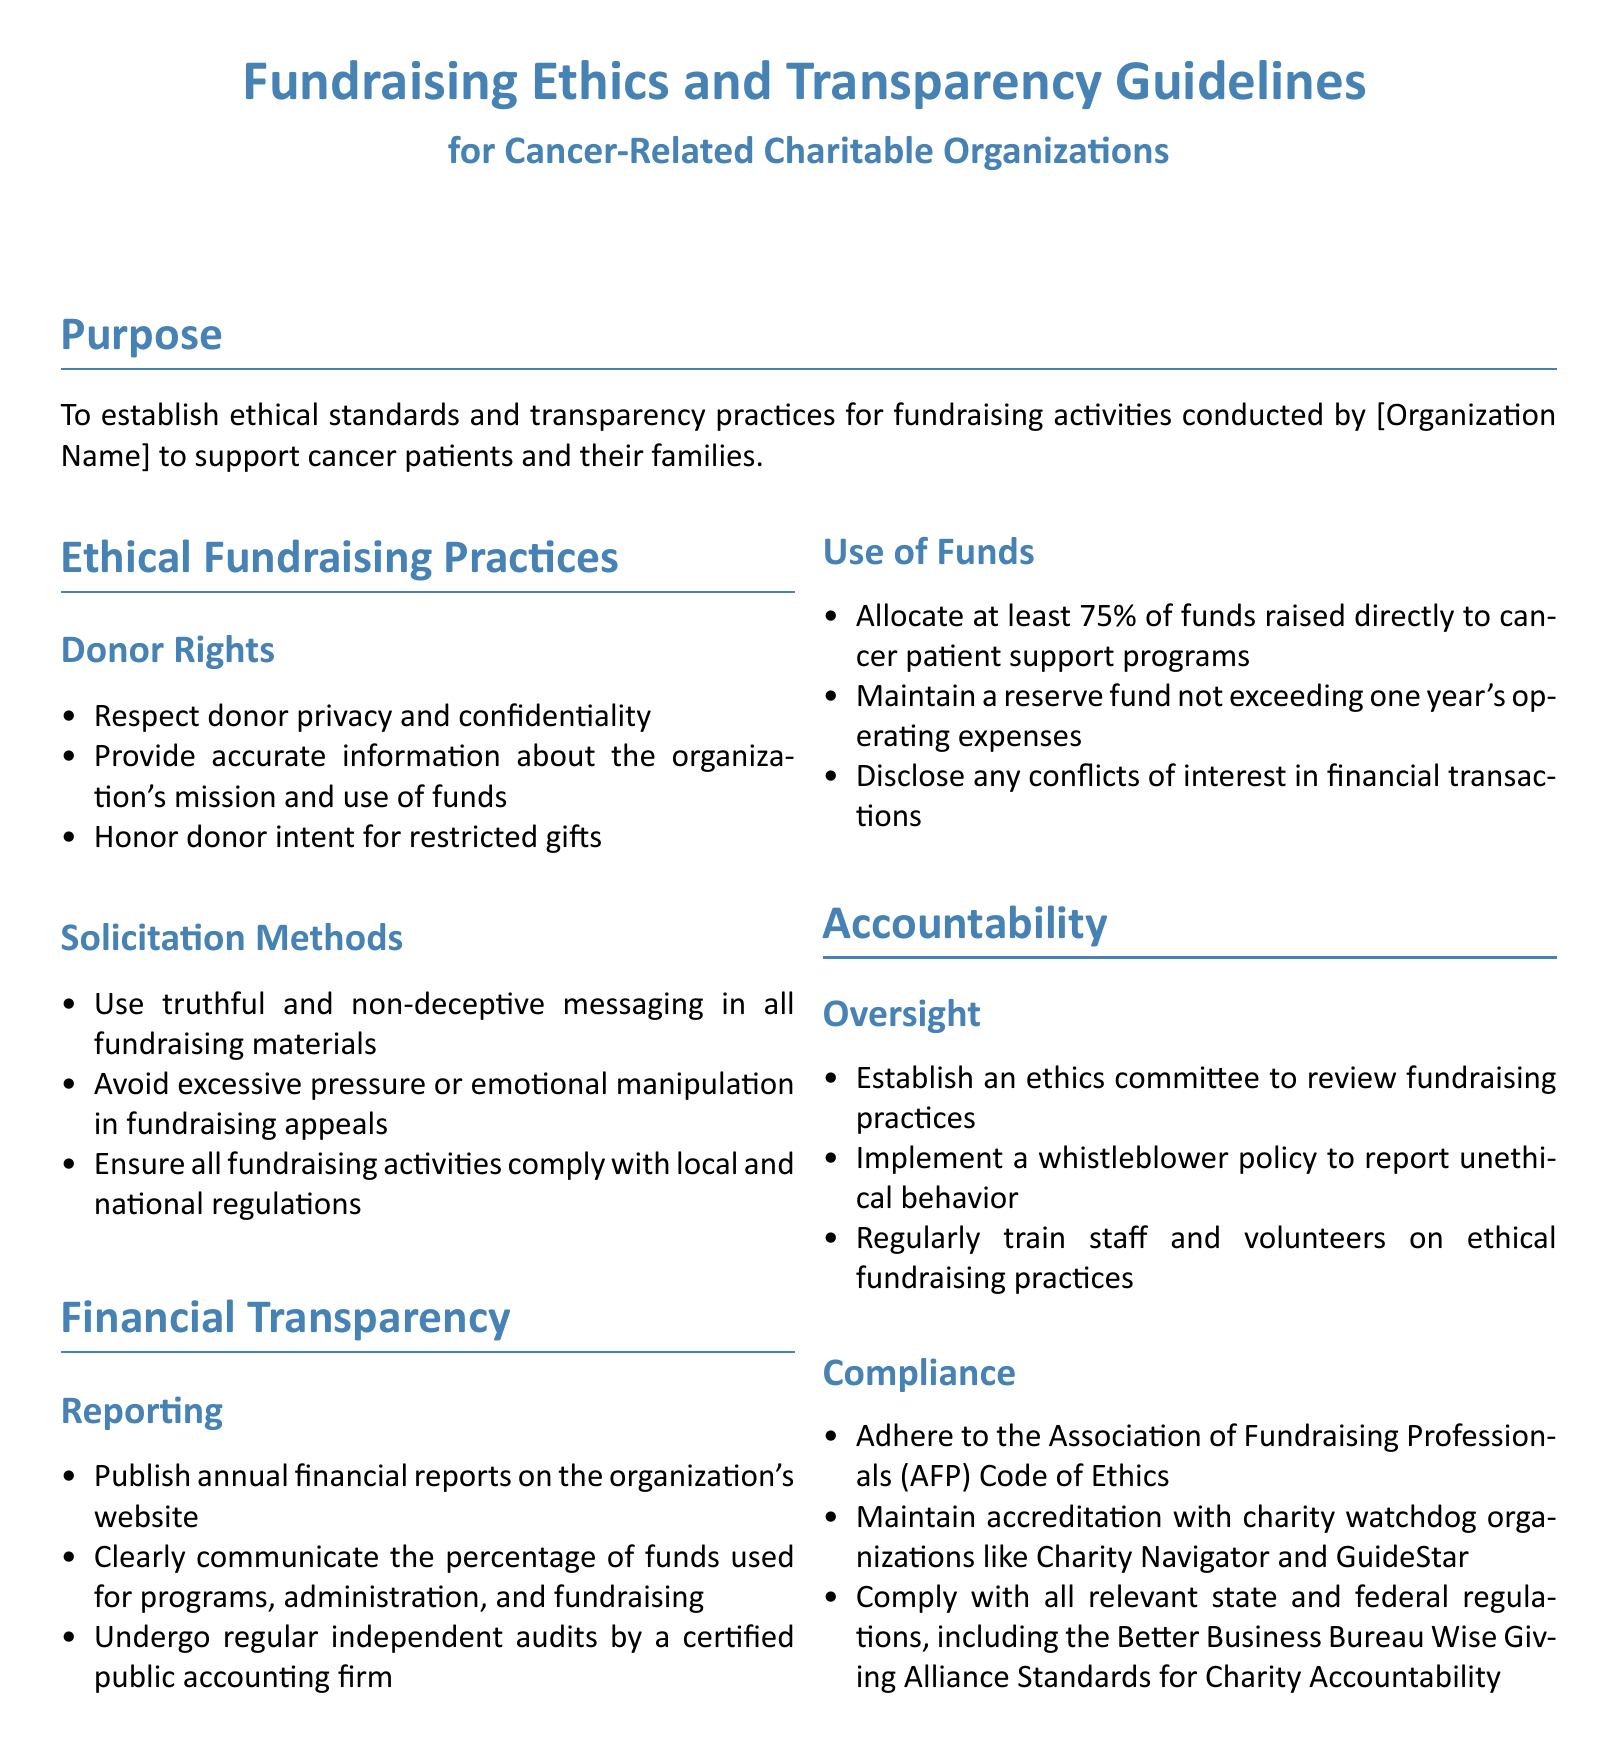What is the main purpose of the guidelines? The guidelines aim to establish ethical standards and transparency practices for fundraising activities conducted by the organization to support cancer patients and their families.
Answer: To establish ethical standards and transparency practices for fundraising activities Who should receive 75% of the funds raised? The guidelines state that at least 75% of funds should be allocated to cancer patient support programs.
Answer: Cancer patient support programs What is included in the donor rights section? The document lists several rights under donor rights, including respecting privacy and providing accurate information.
Answer: Respect donor privacy and confidentiality What organization’s code of ethics must be adhered to? The guidelines require compliance with the Association of Fundraising Professionals Code of Ethics.
Answer: Association of Fundraising Professionals How often should financial reports be published? The guidelines specify that annual financial reports should be published on the organization's website.
Answer: Annual How many years’ operating expenses can reserve funds exceed? The document states that reserve funds should not exceed one year’s operating expenses.
Answer: One year What must be established to review fundraising practices? The guidelines specify that an ethics committee must be established for reviewing fundraising practices.
Answer: An ethics committee What must organizations undergo regularly? The guidelines state that organizations should undergo regular independent audits by a certified public accounting firm.
Answer: Regular independent audits What practice is recommended for reporting unethical behavior? The guidelines recommend implementing a whistleblower policy to report unethical behavior.
Answer: Whistleblower policy 